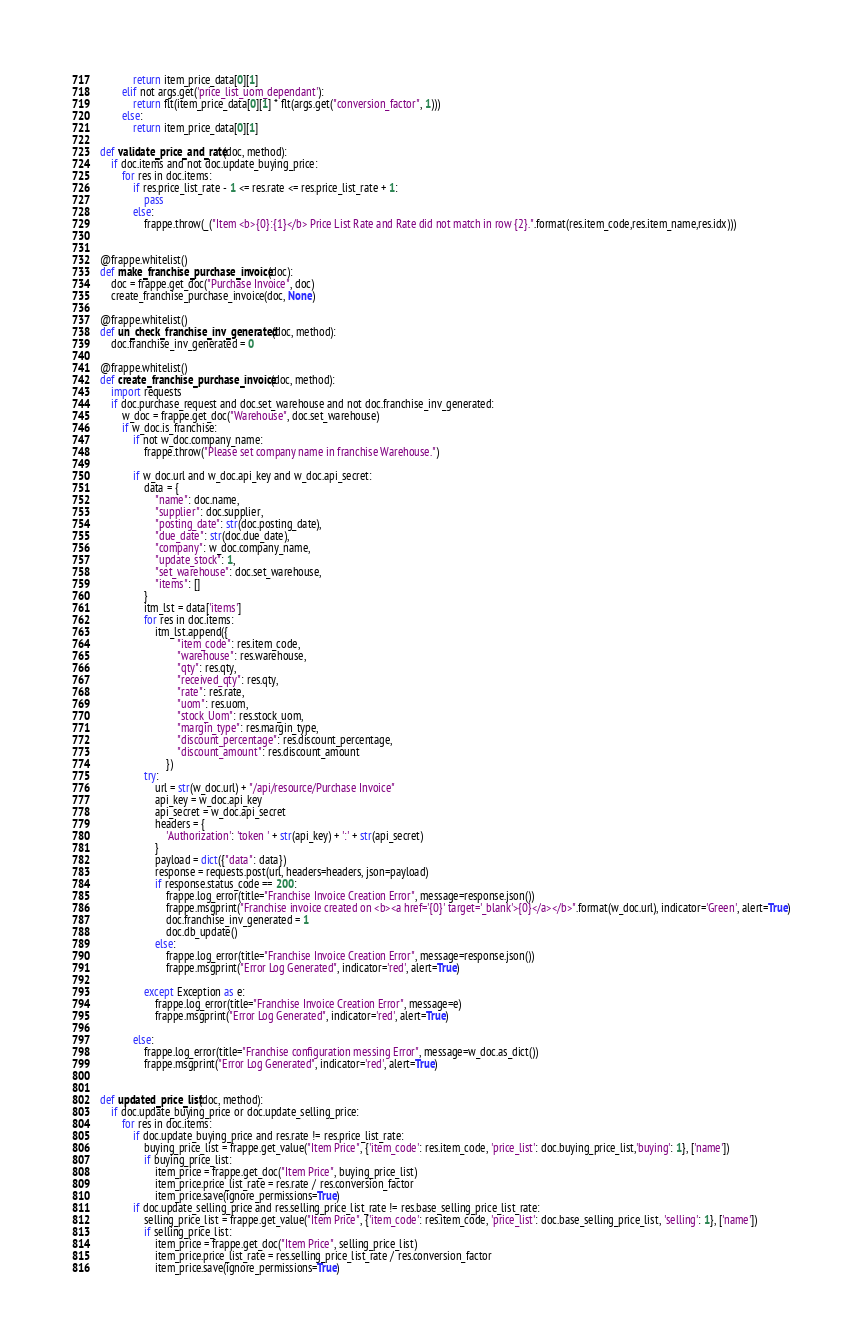<code> <loc_0><loc_0><loc_500><loc_500><_Python_>            return item_price_data[0][1]
        elif not args.get('price_list_uom_dependant'):
            return flt(item_price_data[0][1] * flt(args.get("conversion_factor", 1)))
        else:
            return item_price_data[0][1]

def validate_price_and_rate(doc, method):
    if doc.items and not doc.update_buying_price:
        for res in doc.items:
            if res.price_list_rate - 1 <= res.rate <= res.price_list_rate + 1:
                pass
            else:
                frappe.throw(_("Item <b>{0}:{1}</b> Price List Rate and Rate did not match in row {2}.".format(res.item_code,res.item_name,res.idx)))


@frappe.whitelist()
def make_franchise_purchase_invoice(doc):
    doc = frappe.get_doc("Purchase Invoice", doc)
    create_franchise_purchase_invoice(doc, None)

@frappe.whitelist()
def un_check_franchise_inv_generated(doc, method):
    doc.franchise_inv_generated = 0

@frappe.whitelist()
def create_franchise_purchase_invoice(doc, method):
    import requests
    if doc.purchase_request and doc.set_warehouse and not doc.franchise_inv_generated:
        w_doc = frappe.get_doc("Warehouse", doc.set_warehouse)
        if w_doc.is_franchise:
            if not w_doc.company_name:
                frappe.throw("Please set company name in franchise Warehouse.")

            if w_doc.url and w_doc.api_key and w_doc.api_secret:
                data = {
                    "name": doc.name,
                    "supplier": doc.supplier,
                    "posting_date": str(doc.posting_date),
                    "due_date": str(doc.due_date),
                    "company": w_doc.company_name,
                    "update_stock": 1,
                    "set_warehouse": doc.set_warehouse,
                    "items": []
                }
                itm_lst = data['items']
                for res in doc.items:
                    itm_lst.append({
                            "item_code": res.item_code,
                            "warehouse": res.warehouse,
                            "qty": res.qty,
                            "received_qty": res.qty,
                            "rate": res.rate,
                            "uom": res.uom,
                            "stock_Uom": res.stock_uom,
                            "margin_type": res.margin_type,
                            "discount_percentage": res.discount_percentage,
                            "discount_amount": res.discount_amount
                        })
                try:
                    url = str(w_doc.url) + "/api/resource/Purchase Invoice"
                    api_key = w_doc.api_key
                    api_secret = w_doc.api_secret
                    headers = {
                        'Authorization': 'token ' + str(api_key) + ':' + str(api_secret)
                    }
                    payload = dict({"data": data})
                    response = requests.post(url, headers=headers, json=payload)
                    if response.status_code == 200:
                        frappe.log_error(title="Franchise Invoice Creation Error", message=response.json())
                        frappe.msgprint("Franchise invoice created on <b><a href='{0}' target='_blank'>{0}</a></b>".format(w_doc.url), indicator='Green', alert=True)
                        doc.franchise_inv_generated = 1
                        doc.db_update()
                    else:
                        frappe.log_error(title="Franchise Invoice Creation Error", message=response.json())
                        frappe.msgprint("Error Log Generated", indicator='red', alert=True)

                except Exception as e:
                    frappe.log_error(title="Franchise Invoice Creation Error", message=e)
                    frappe.msgprint("Error Log Generated", indicator='red', alert=True)

            else:
                frappe.log_error(title="Franchise configuration messing Error", message=w_doc.as_dict())
                frappe.msgprint("Error Log Generated", indicator='red', alert=True)


def updated_price_list(doc, method):
    if doc.update_buying_price or doc.update_selling_price:
        for res in doc.items:
            if doc.update_buying_price and res.rate != res.price_list_rate:
                buying_price_list = frappe.get_value("Item Price", {'item_code': res.item_code, 'price_list': doc.buying_price_list,'buying': 1}, ['name'])
                if buying_price_list:
                    item_price = frappe.get_doc("Item Price", buying_price_list)
                    item_price.price_list_rate = res.rate / res.conversion_factor
                    item_price.save(ignore_permissions=True)
            if doc.update_selling_price and res.selling_price_list_rate != res.base_selling_price_list_rate:
                selling_price_list = frappe.get_value("Item Price", {'item_code': res.item_code, 'price_list': doc.base_selling_price_list, 'selling': 1}, ['name'])
                if selling_price_list:
                    item_price = frappe.get_doc("Item Price", selling_price_list)
                    item_price.price_list_rate = res.selling_price_list_rate / res.conversion_factor
                    item_price.save(ignore_permissions=True)
</code> 